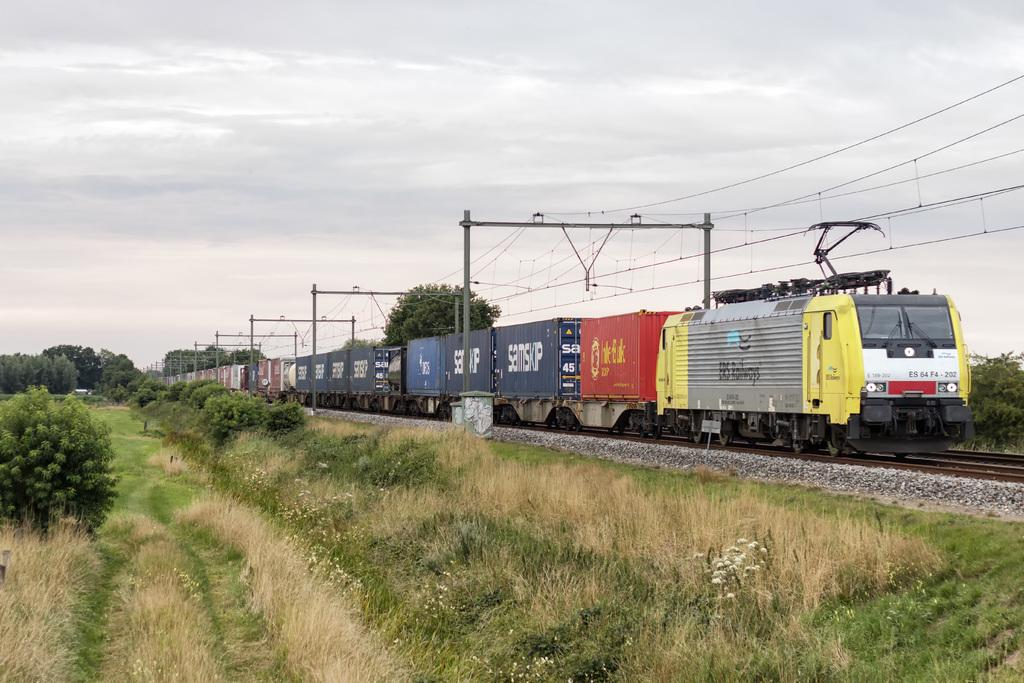<image>
Describe the image concisely. a samskip sign on the side of a train 